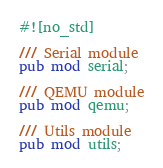<code> <loc_0><loc_0><loc_500><loc_500><_Rust_>#![no_std]

/// Serial module
pub mod serial;

/// QEMU module
pub mod qemu;

/// Utils module
pub mod utils;</code> 